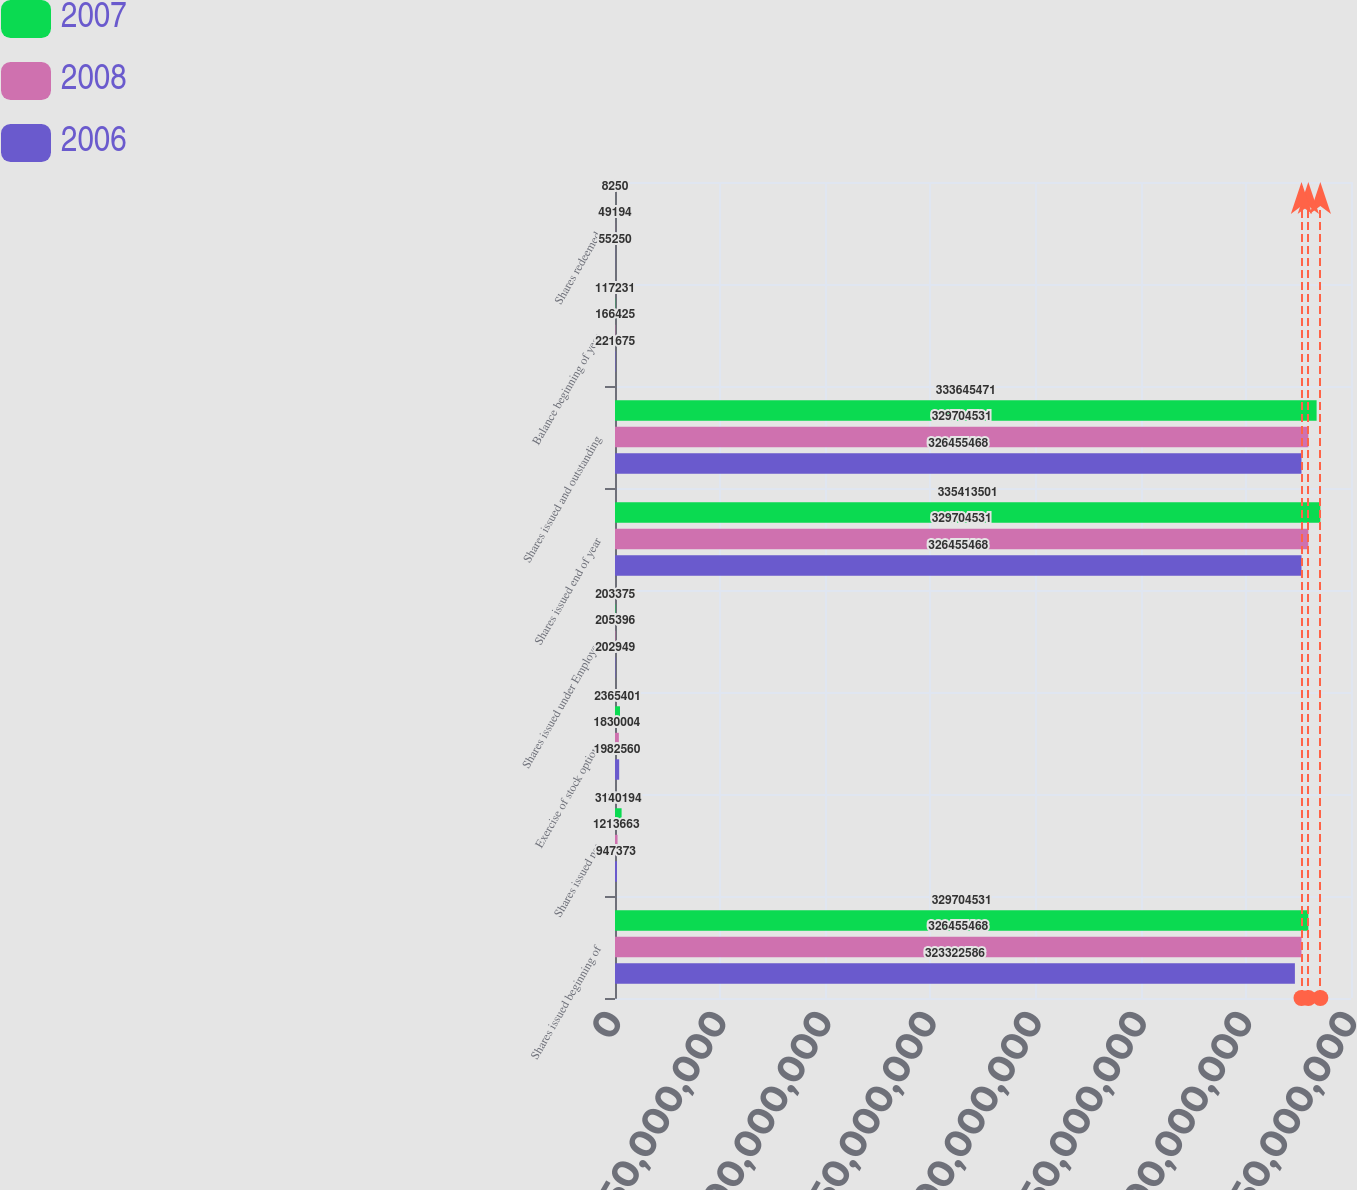Convert chart. <chart><loc_0><loc_0><loc_500><loc_500><stacked_bar_chart><ecel><fcel>Shares issued beginning of<fcel>Shares issued net<fcel>Exercise of stock options<fcel>Shares issued under Employee<fcel>Shares issued end of year<fcel>Shares issued and outstanding<fcel>Balance beginning of year<fcel>Shares redeemed<nl><fcel>2007<fcel>3.29705e+08<fcel>3.14019e+06<fcel>2.3654e+06<fcel>203375<fcel>3.35414e+08<fcel>3.33645e+08<fcel>117231<fcel>8250<nl><fcel>2008<fcel>3.26455e+08<fcel>1.21366e+06<fcel>1.83e+06<fcel>205396<fcel>3.29705e+08<fcel>3.29705e+08<fcel>166425<fcel>49194<nl><fcel>2006<fcel>3.23323e+08<fcel>947373<fcel>1.98256e+06<fcel>202949<fcel>3.26455e+08<fcel>3.26455e+08<fcel>221675<fcel>55250<nl></chart> 